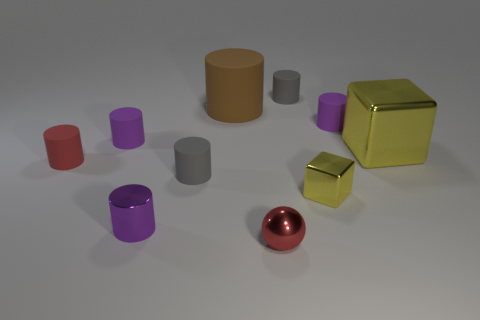There is a red matte object; is it the same size as the block to the right of the small yellow shiny thing?
Your response must be concise. No. Is the number of large blue rubber cylinders the same as the number of big objects?
Your answer should be compact. No. How many small purple metallic cylinders are to the right of the tiny gray rubber thing that is in front of the gray rubber cylinder that is behind the large shiny cube?
Make the answer very short. 0. There is a small red matte cylinder; how many small yellow shiny blocks are behind it?
Your answer should be very brief. 0. There is a big rubber cylinder behind the gray cylinder that is in front of the large brown matte cylinder; what is its color?
Your answer should be compact. Brown. What number of other things are there of the same material as the small red sphere
Your answer should be very brief. 3. Are there the same number of small yellow cubes in front of the small shiny cube and tiny red balls?
Provide a short and direct response. No. What is the material of the yellow thing on the left side of the purple cylinder that is right of the tiny purple cylinder in front of the tiny red cylinder?
Provide a short and direct response. Metal. There is a tiny rubber object to the right of the small cube; what is its color?
Your answer should be very brief. Purple. Is there anything else that has the same shape as the large yellow thing?
Give a very brief answer. Yes. 